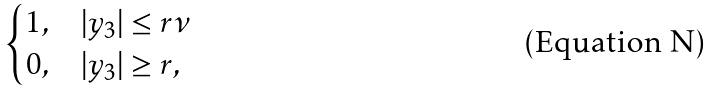Convert formula to latex. <formula><loc_0><loc_0><loc_500><loc_500>\begin{cases} 1 , & | y _ { 3 } | \leq r \nu \\ 0 , & | y _ { 3 } | \geq r , \end{cases}</formula> 